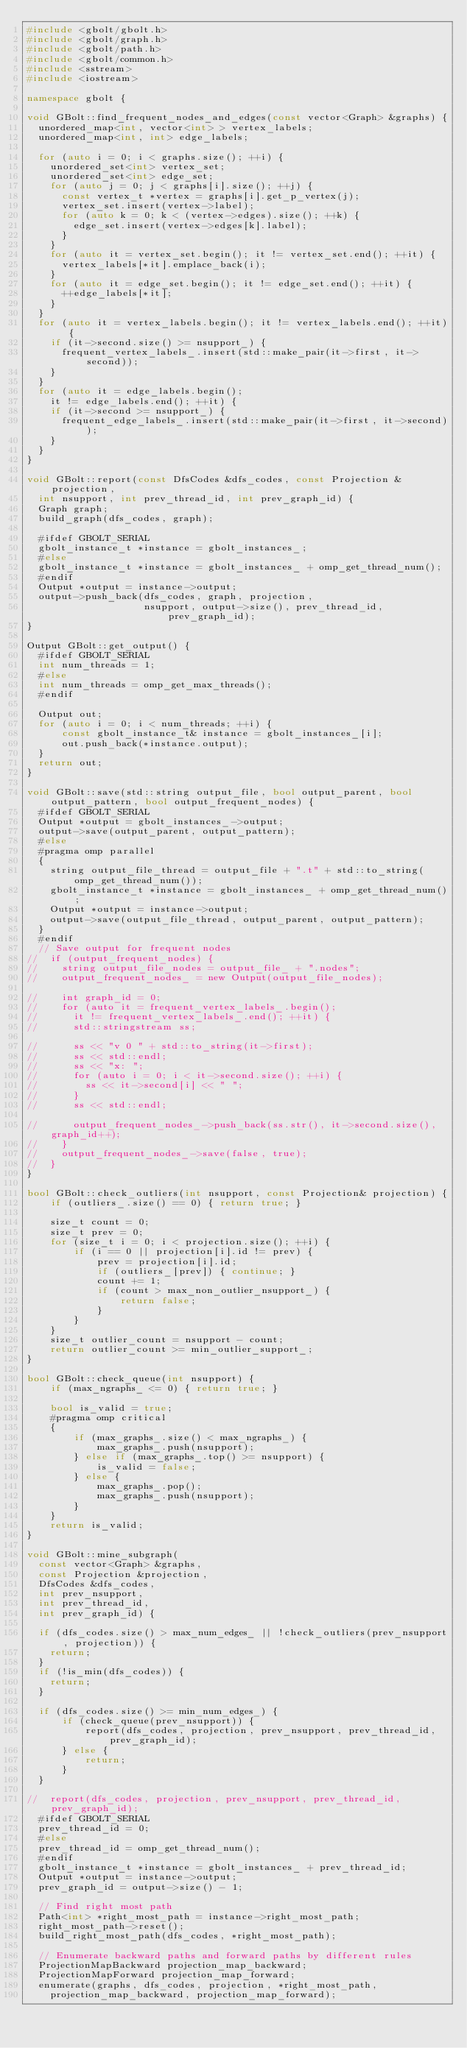Convert code to text. <code><loc_0><loc_0><loc_500><loc_500><_C++_>#include <gbolt/gbolt.h>
#include <gbolt/graph.h>
#include <gbolt/path.h>
#include <gbolt/common.h>
#include <sstream>
#include <iostream>

namespace gbolt {

void GBolt::find_frequent_nodes_and_edges(const vector<Graph> &graphs) {
  unordered_map<int, vector<int> > vertex_labels;
  unordered_map<int, int> edge_labels;

  for (auto i = 0; i < graphs.size(); ++i) {
    unordered_set<int> vertex_set;
    unordered_set<int> edge_set;
    for (auto j = 0; j < graphs[i].size(); ++j) {
      const vertex_t *vertex = graphs[i].get_p_vertex(j);
      vertex_set.insert(vertex->label);
      for (auto k = 0; k < (vertex->edges).size(); ++k) {
        edge_set.insert(vertex->edges[k].label);
      }
    }
    for (auto it = vertex_set.begin(); it != vertex_set.end(); ++it) {
      vertex_labels[*it].emplace_back(i);
    }
    for (auto it = edge_set.begin(); it != edge_set.end(); ++it) {
      ++edge_labels[*it];
    }
  }
  for (auto it = vertex_labels.begin(); it != vertex_labels.end(); ++it) {
    if (it->second.size() >= nsupport_) {
      frequent_vertex_labels_.insert(std::make_pair(it->first, it->second));
    }
  }
  for (auto it = edge_labels.begin();
    it != edge_labels.end(); ++it) {
    if (it->second >= nsupport_) {
      frequent_edge_labels_.insert(std::make_pair(it->first, it->second));
    }
  }
}

void GBolt::report(const DfsCodes &dfs_codes, const Projection &projection,
  int nsupport, int prev_thread_id, int prev_graph_id) {
  Graph graph;
  build_graph(dfs_codes, graph);

  #ifdef GBOLT_SERIAL
  gbolt_instance_t *instance = gbolt_instances_;
  #else
  gbolt_instance_t *instance = gbolt_instances_ + omp_get_thread_num();
  #endif
  Output *output = instance->output;
  output->push_back(dfs_codes, graph, projection,
					nsupport, output->size(), prev_thread_id, prev_graph_id);
}

Output GBolt::get_output() {
  #ifdef GBOLT_SERIAL
  int num_threads = 1;
  #else
  int num_threads = omp_get_max_threads();
  #endif

  Output out;
  for (auto i = 0; i < num_threads; ++i) {
	  const gbolt_instance_t& instance = gbolt_instances_[i];
	  out.push_back(*instance.output);
  }
  return out;
}

void GBolt::save(std::string output_file, bool output_parent, bool output_pattern, bool output_frequent_nodes) {
  #ifdef GBOLT_SERIAL
  Output *output = gbolt_instances_->output;
  output->save(output_parent, output_pattern);
  #else
  #pragma omp parallel
  {
	string output_file_thread = output_file + ".t" + std::to_string(omp_get_thread_num());
	gbolt_instance_t *instance = gbolt_instances_ + omp_get_thread_num();
	Output *output = instance->output;
	output->save(output_file_thread, output_parent, output_pattern);
  }
  #endif
  // Save output for frequent nodes
//  if (output_frequent_nodes) {
//    string output_file_nodes = output_file_ + ".nodes";
//    output_frequent_nodes_ = new Output(output_file_nodes);

//    int graph_id = 0;
//    for (auto it = frequent_vertex_labels_.begin();
//      it != frequent_vertex_labels_.end(); ++it) {
//      std::stringstream ss;

//      ss << "v 0 " + std::to_string(it->first);
//      ss << std::endl;
//      ss << "x: ";
//      for (auto i = 0; i < it->second.size(); ++i) {
//        ss << it->second[i] << " ";
//      }
//      ss << std::endl;

//      output_frequent_nodes_->push_back(ss.str(), it->second.size(), graph_id++);
//    }
//    output_frequent_nodes_->save(false, true);
//  }
}

bool GBolt::check_outliers(int nsupport, const Projection& projection) {
	if (outliers_.size() == 0) { return true; }

	size_t count = 0;
	size_t prev = 0;
	for (size_t i = 0; i < projection.size(); ++i) {
		if (i == 0 || projection[i].id != prev) {
			prev = projection[i].id;
			if (outliers_[prev]) { continue; }
			count += 1;
			if (count > max_non_outlier_nsupport_) {
				return false;
			}
		}
	}
	size_t outlier_count = nsupport - count;
	return outlier_count >= min_outlier_support_;
}

bool GBolt::check_queue(int nsupport) {
	if (max_ngraphs_ <= 0) { return true; }

	bool is_valid = true;
	#pragma omp critical
	{
		if (max_graphs_.size() < max_ngraphs_) {
			max_graphs_.push(nsupport);
		} else if (max_graphs_.top() >= nsupport) {
			is_valid = false;
		} else {
			max_graphs_.pop();
			max_graphs_.push(nsupport);
		}
	}
	return is_valid;
}

void GBolt::mine_subgraph(
  const vector<Graph> &graphs,
  const Projection &projection,
  DfsCodes &dfs_codes,
  int prev_nsupport,
  int prev_thread_id,
  int prev_graph_id) {

  if (dfs_codes.size() > max_num_edges_ || !check_outliers(prev_nsupport, projection)) {
	return;
  }
  if (!is_min(dfs_codes)) {
	return;
  }

  if (dfs_codes.size() >= min_num_edges_) {
	  if (check_queue(prev_nsupport)) {
		  report(dfs_codes, projection, prev_nsupport, prev_thread_id, prev_graph_id);
	  } else {
		  return;
	  }
  }

//  report(dfs_codes, projection, prev_nsupport, prev_thread_id, prev_graph_id);
  #ifdef GBOLT_SERIAL
  prev_thread_id = 0;
  #else
  prev_thread_id = omp_get_thread_num();
  #endif
  gbolt_instance_t *instance = gbolt_instances_ + prev_thread_id;
  Output *output = instance->output;
  prev_graph_id = output->size() - 1;

  // Find right most path
  Path<int> *right_most_path = instance->right_most_path;
  right_most_path->reset();
  build_right_most_path(dfs_codes, *right_most_path);

  // Enumerate backward paths and forward paths by different rules
  ProjectionMapBackward projection_map_backward;
  ProjectionMapForward projection_map_forward;
  enumerate(graphs, dfs_codes, projection, *right_most_path,
    projection_map_backward, projection_map_forward);</code> 